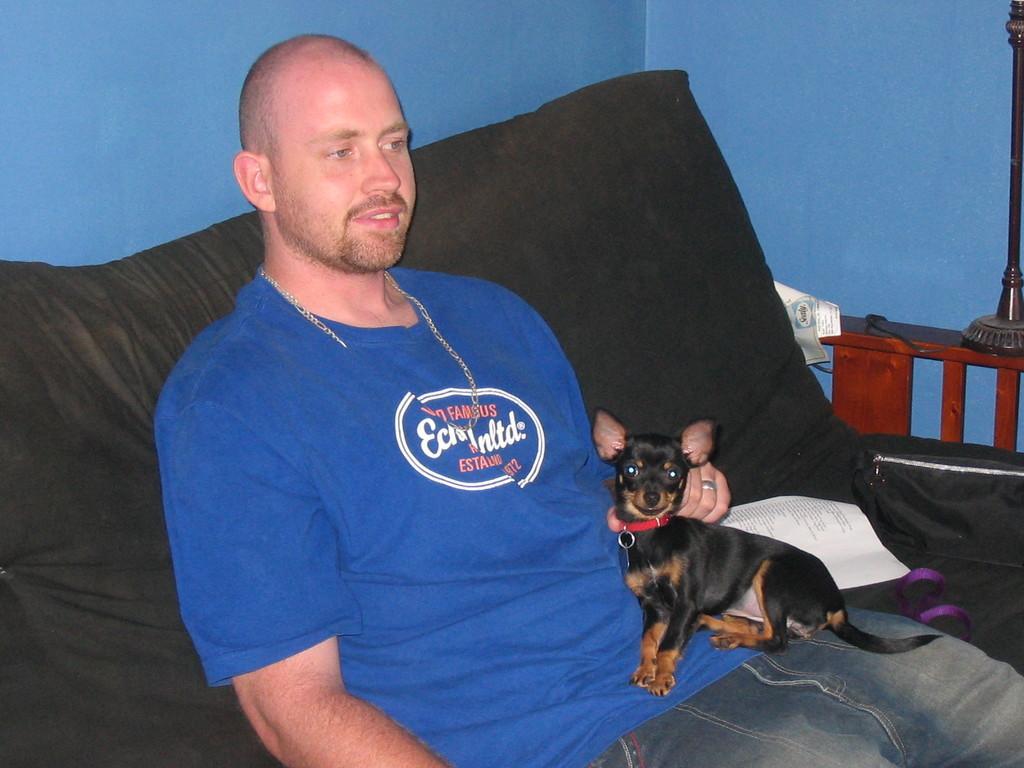How would you summarize this image in a sentence or two? This picture shows a man seated on the couch and holds dog with his hand and we see a paper 